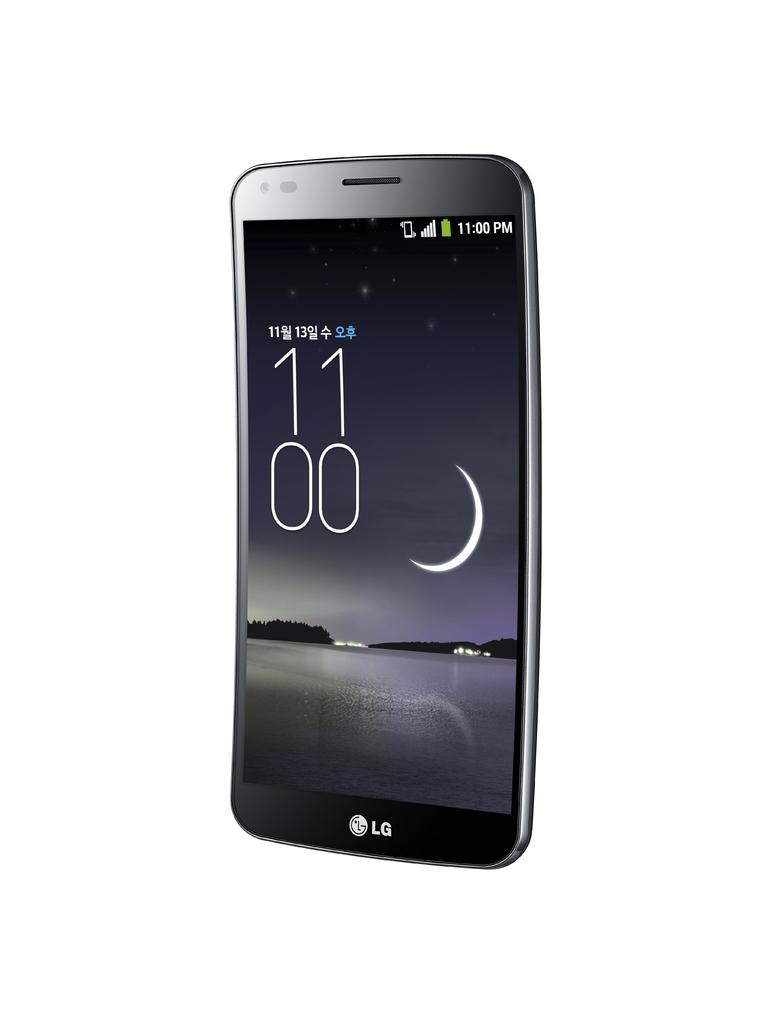<image>
Offer a succinct explanation of the picture presented. An LG phone displaying the time 11:00 p.m. and showing the image of a crescent moon. 